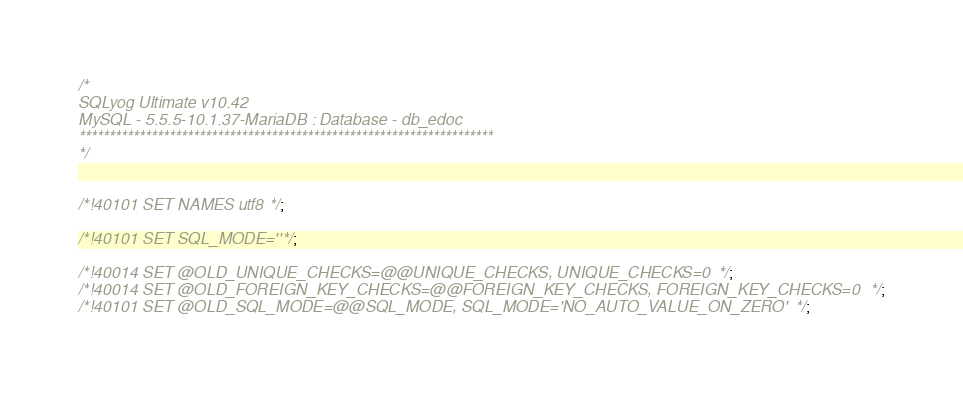<code> <loc_0><loc_0><loc_500><loc_500><_SQL_>/*
SQLyog Ultimate v10.42 
MySQL - 5.5.5-10.1.37-MariaDB : Database - db_edoc
*********************************************************************
*/

/*!40101 SET NAMES utf8 */;

/*!40101 SET SQL_MODE=''*/;

/*!40014 SET @OLD_UNIQUE_CHECKS=@@UNIQUE_CHECKS, UNIQUE_CHECKS=0 */;
/*!40014 SET @OLD_FOREIGN_KEY_CHECKS=@@FOREIGN_KEY_CHECKS, FOREIGN_KEY_CHECKS=0 */;
/*!40101 SET @OLD_SQL_MODE=@@SQL_MODE, SQL_MODE='NO_AUTO_VALUE_ON_ZERO' */;</code> 